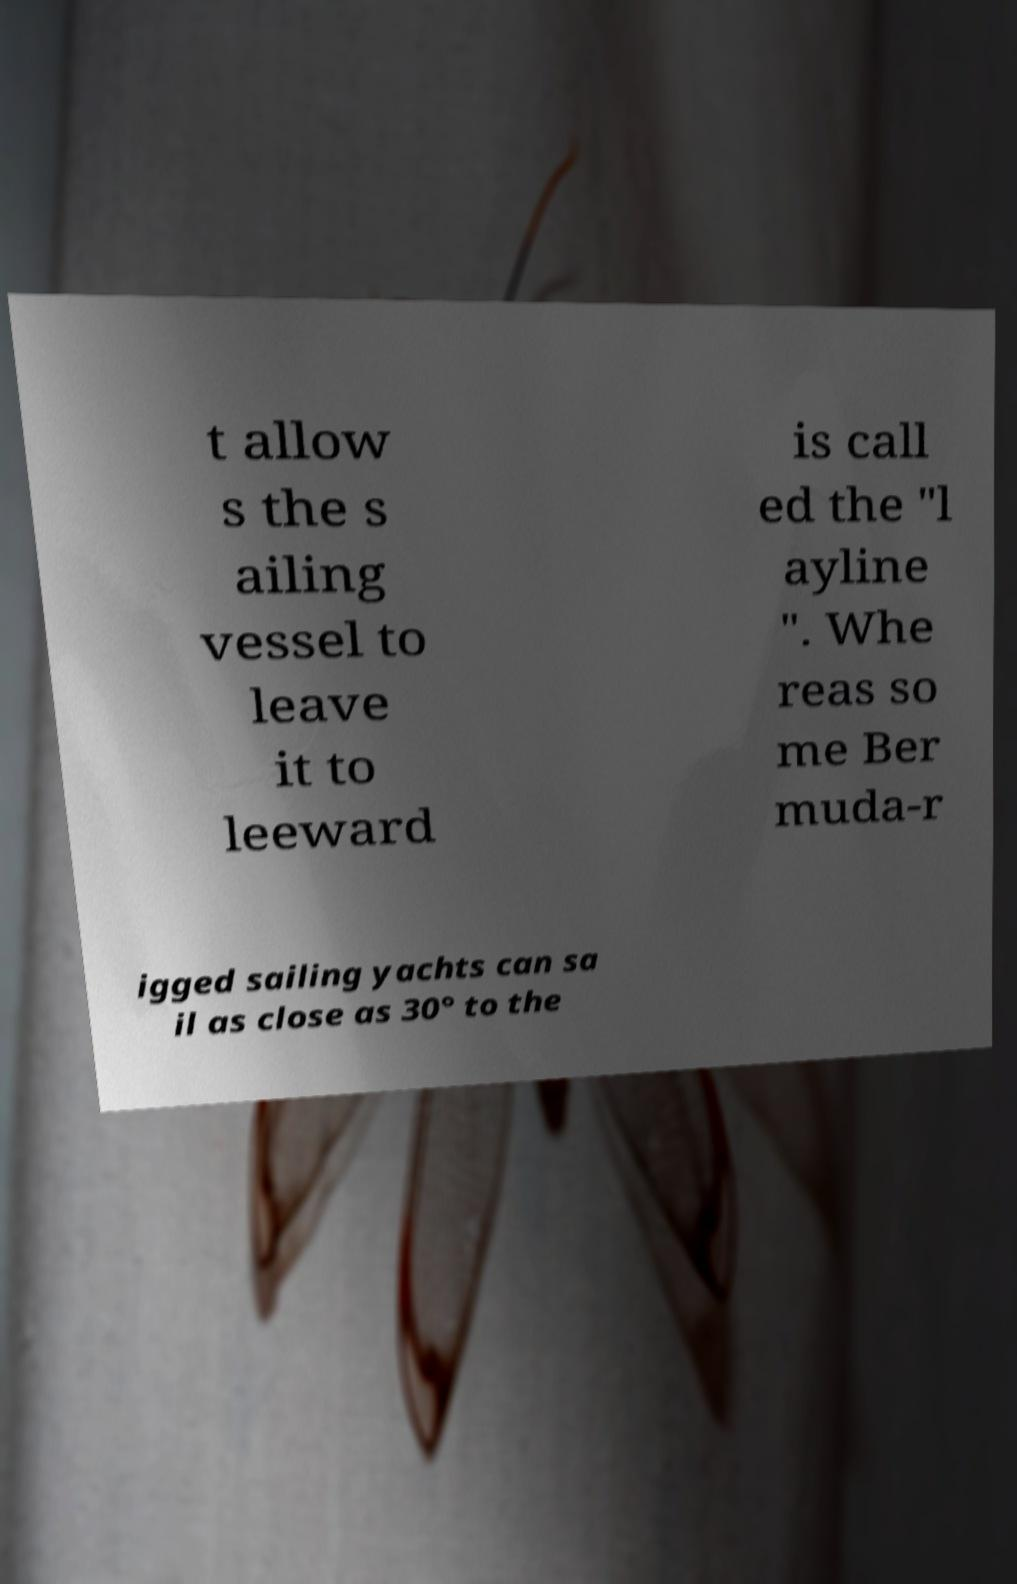For documentation purposes, I need the text within this image transcribed. Could you provide that? t allow s the s ailing vessel to leave it to leeward is call ed the "l ayline ". Whe reas so me Ber muda-r igged sailing yachts can sa il as close as 30° to the 